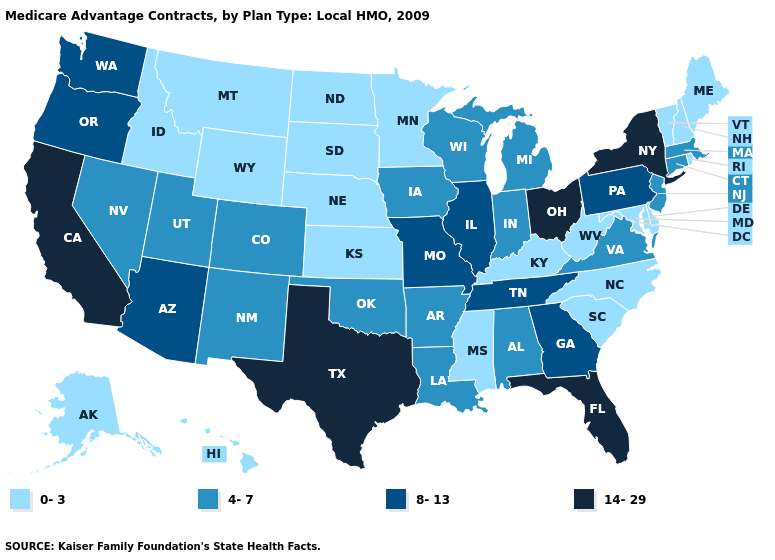What is the value of Nebraska?
Answer briefly. 0-3. Name the states that have a value in the range 8-13?
Concise answer only. Arizona, Georgia, Illinois, Missouri, Oregon, Pennsylvania, Tennessee, Washington. What is the lowest value in the Northeast?
Give a very brief answer. 0-3. Among the states that border Ohio , does Indiana have the highest value?
Short answer required. No. What is the value of Minnesota?
Give a very brief answer. 0-3. Which states hav the highest value in the MidWest?
Write a very short answer. Ohio. Name the states that have a value in the range 14-29?
Be succinct. California, Florida, New York, Ohio, Texas. Name the states that have a value in the range 8-13?
Concise answer only. Arizona, Georgia, Illinois, Missouri, Oregon, Pennsylvania, Tennessee, Washington. Does Colorado have the lowest value in the West?
Give a very brief answer. No. Does Nevada have the lowest value in the West?
Give a very brief answer. No. What is the value of California?
Be succinct. 14-29. Which states have the highest value in the USA?
Quick response, please. California, Florida, New York, Ohio, Texas. What is the highest value in the USA?
Write a very short answer. 14-29. Does Arkansas have the highest value in the South?
Quick response, please. No. What is the highest value in states that border Wisconsin?
Be succinct. 8-13. 